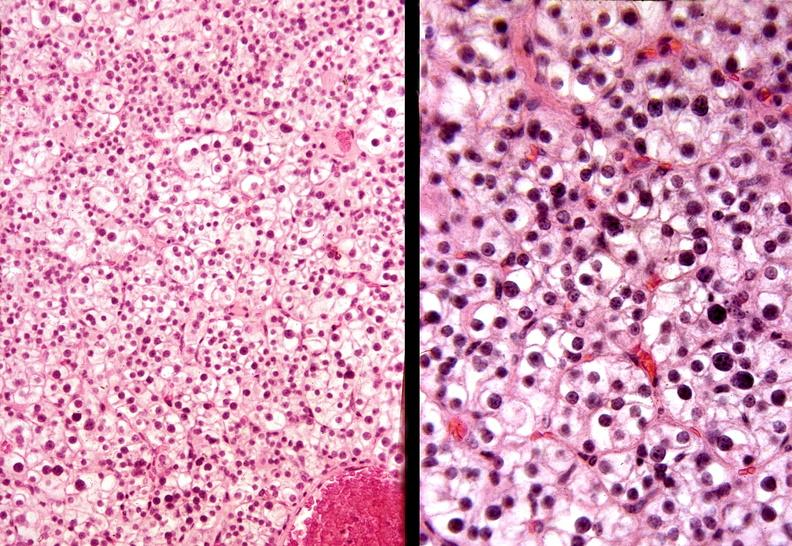what is present?
Answer the question using a single word or phrase. Endocrine 